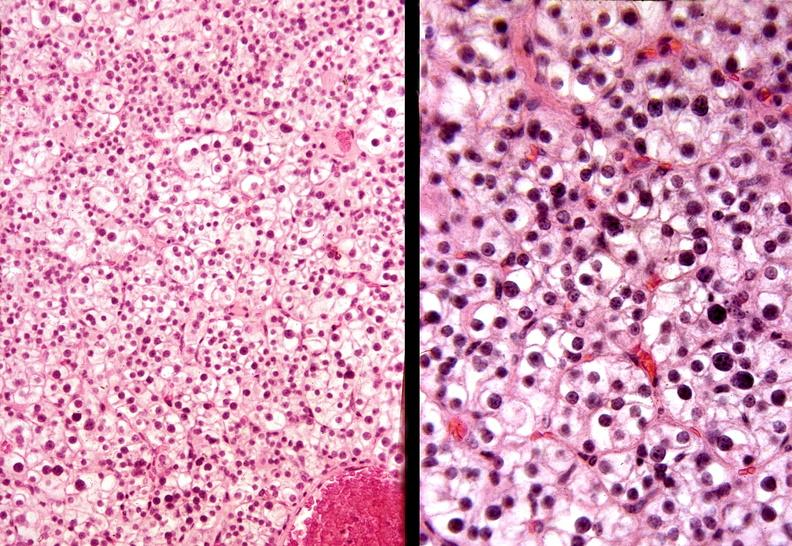what is present?
Answer the question using a single word or phrase. Endocrine 